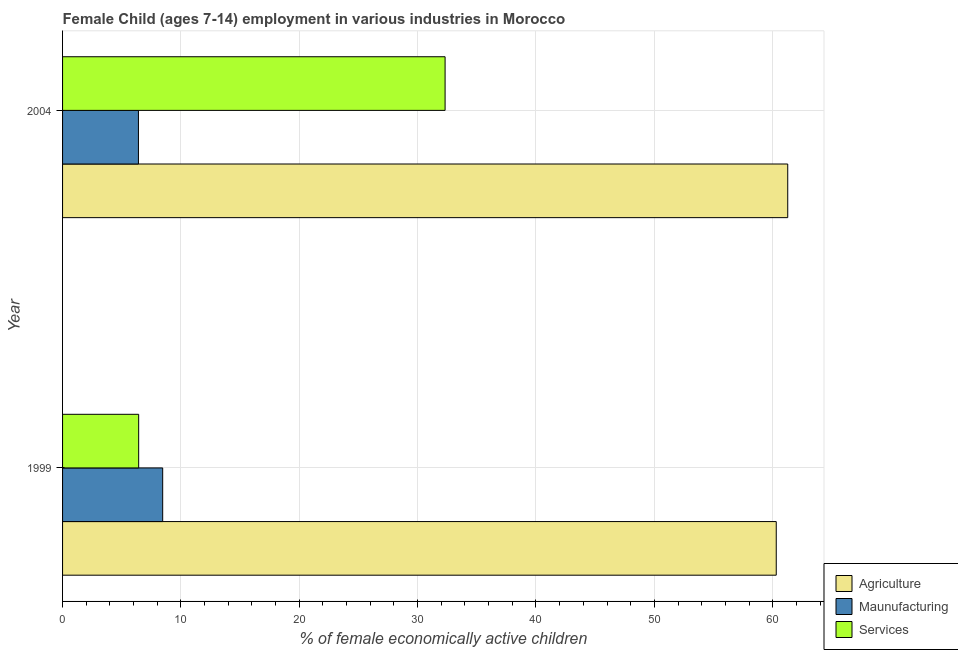How many bars are there on the 2nd tick from the top?
Ensure brevity in your answer.  3. What is the label of the 1st group of bars from the top?
Keep it short and to the point. 2004. What is the percentage of economically active children in services in 2004?
Your answer should be compact. 32.32. Across all years, what is the maximum percentage of economically active children in agriculture?
Make the answer very short. 61.27. Across all years, what is the minimum percentage of economically active children in services?
Your response must be concise. 6.43. In which year was the percentage of economically active children in agriculture minimum?
Your response must be concise. 1999. What is the total percentage of economically active children in services in the graph?
Provide a succinct answer. 38.75. What is the difference between the percentage of economically active children in manufacturing in 1999 and that in 2004?
Make the answer very short. 2.05. What is the difference between the percentage of economically active children in services in 2004 and the percentage of economically active children in agriculture in 1999?
Provide a short and direct response. -27.98. What is the average percentage of economically active children in manufacturing per year?
Your answer should be compact. 7.43. In the year 2004, what is the difference between the percentage of economically active children in manufacturing and percentage of economically active children in agriculture?
Provide a short and direct response. -54.86. In how many years, is the percentage of economically active children in agriculture greater than 26 %?
Your response must be concise. 2. What is the ratio of the percentage of economically active children in services in 1999 to that in 2004?
Provide a succinct answer. 0.2. Is the percentage of economically active children in agriculture in 1999 less than that in 2004?
Offer a terse response. Yes. In how many years, is the percentage of economically active children in services greater than the average percentage of economically active children in services taken over all years?
Offer a terse response. 1. What does the 1st bar from the top in 1999 represents?
Your answer should be compact. Services. What does the 2nd bar from the bottom in 2004 represents?
Provide a short and direct response. Maunufacturing. How many bars are there?
Keep it short and to the point. 6. What is the difference between two consecutive major ticks on the X-axis?
Ensure brevity in your answer.  10. Does the graph contain grids?
Provide a short and direct response. Yes. What is the title of the graph?
Ensure brevity in your answer.  Female Child (ages 7-14) employment in various industries in Morocco. Does "Hydroelectric sources" appear as one of the legend labels in the graph?
Ensure brevity in your answer.  No. What is the label or title of the X-axis?
Offer a very short reply. % of female economically active children. What is the % of female economically active children in Agriculture in 1999?
Offer a terse response. 60.3. What is the % of female economically active children of Maunufacturing in 1999?
Provide a succinct answer. 8.46. What is the % of female economically active children of Services in 1999?
Your answer should be compact. 6.43. What is the % of female economically active children in Agriculture in 2004?
Make the answer very short. 61.27. What is the % of female economically active children of Maunufacturing in 2004?
Your answer should be very brief. 6.41. What is the % of female economically active children of Services in 2004?
Your response must be concise. 32.32. Across all years, what is the maximum % of female economically active children of Agriculture?
Offer a very short reply. 61.27. Across all years, what is the maximum % of female economically active children in Maunufacturing?
Ensure brevity in your answer.  8.46. Across all years, what is the maximum % of female economically active children of Services?
Your answer should be very brief. 32.32. Across all years, what is the minimum % of female economically active children in Agriculture?
Your response must be concise. 60.3. Across all years, what is the minimum % of female economically active children of Maunufacturing?
Offer a terse response. 6.41. Across all years, what is the minimum % of female economically active children in Services?
Ensure brevity in your answer.  6.43. What is the total % of female economically active children in Agriculture in the graph?
Offer a terse response. 121.57. What is the total % of female economically active children of Maunufacturing in the graph?
Keep it short and to the point. 14.87. What is the total % of female economically active children of Services in the graph?
Keep it short and to the point. 38.75. What is the difference between the % of female economically active children in Agriculture in 1999 and that in 2004?
Provide a short and direct response. -0.97. What is the difference between the % of female economically active children of Maunufacturing in 1999 and that in 2004?
Ensure brevity in your answer.  2.05. What is the difference between the % of female economically active children of Services in 1999 and that in 2004?
Ensure brevity in your answer.  -25.89. What is the difference between the % of female economically active children in Agriculture in 1999 and the % of female economically active children in Maunufacturing in 2004?
Your answer should be very brief. 53.89. What is the difference between the % of female economically active children in Agriculture in 1999 and the % of female economically active children in Services in 2004?
Offer a very short reply. 27.98. What is the difference between the % of female economically active children in Maunufacturing in 1999 and the % of female economically active children in Services in 2004?
Your answer should be very brief. -23.86. What is the average % of female economically active children of Agriculture per year?
Provide a short and direct response. 60.78. What is the average % of female economically active children in Maunufacturing per year?
Make the answer very short. 7.43. What is the average % of female economically active children of Services per year?
Give a very brief answer. 19.38. In the year 1999, what is the difference between the % of female economically active children in Agriculture and % of female economically active children in Maunufacturing?
Offer a terse response. 51.84. In the year 1999, what is the difference between the % of female economically active children of Agriculture and % of female economically active children of Services?
Provide a succinct answer. 53.87. In the year 1999, what is the difference between the % of female economically active children in Maunufacturing and % of female economically active children in Services?
Provide a succinct answer. 2.03. In the year 2004, what is the difference between the % of female economically active children of Agriculture and % of female economically active children of Maunufacturing?
Offer a very short reply. 54.86. In the year 2004, what is the difference between the % of female economically active children in Agriculture and % of female economically active children in Services?
Your answer should be compact. 28.95. In the year 2004, what is the difference between the % of female economically active children in Maunufacturing and % of female economically active children in Services?
Give a very brief answer. -25.91. What is the ratio of the % of female economically active children of Agriculture in 1999 to that in 2004?
Provide a short and direct response. 0.98. What is the ratio of the % of female economically active children in Maunufacturing in 1999 to that in 2004?
Provide a short and direct response. 1.32. What is the ratio of the % of female economically active children of Services in 1999 to that in 2004?
Offer a terse response. 0.2. What is the difference between the highest and the second highest % of female economically active children of Agriculture?
Ensure brevity in your answer.  0.97. What is the difference between the highest and the second highest % of female economically active children of Maunufacturing?
Ensure brevity in your answer.  2.05. What is the difference between the highest and the second highest % of female economically active children of Services?
Your answer should be compact. 25.89. What is the difference between the highest and the lowest % of female economically active children in Agriculture?
Your answer should be compact. 0.97. What is the difference between the highest and the lowest % of female economically active children in Maunufacturing?
Provide a succinct answer. 2.05. What is the difference between the highest and the lowest % of female economically active children of Services?
Your answer should be very brief. 25.89. 